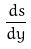Convert formula to latex. <formula><loc_0><loc_0><loc_500><loc_500>\frac { d s } { d y }</formula> 